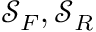Convert formula to latex. <formula><loc_0><loc_0><loc_500><loc_500>\mathcal { S } _ { F } , \mathcal { S } _ { R }</formula> 